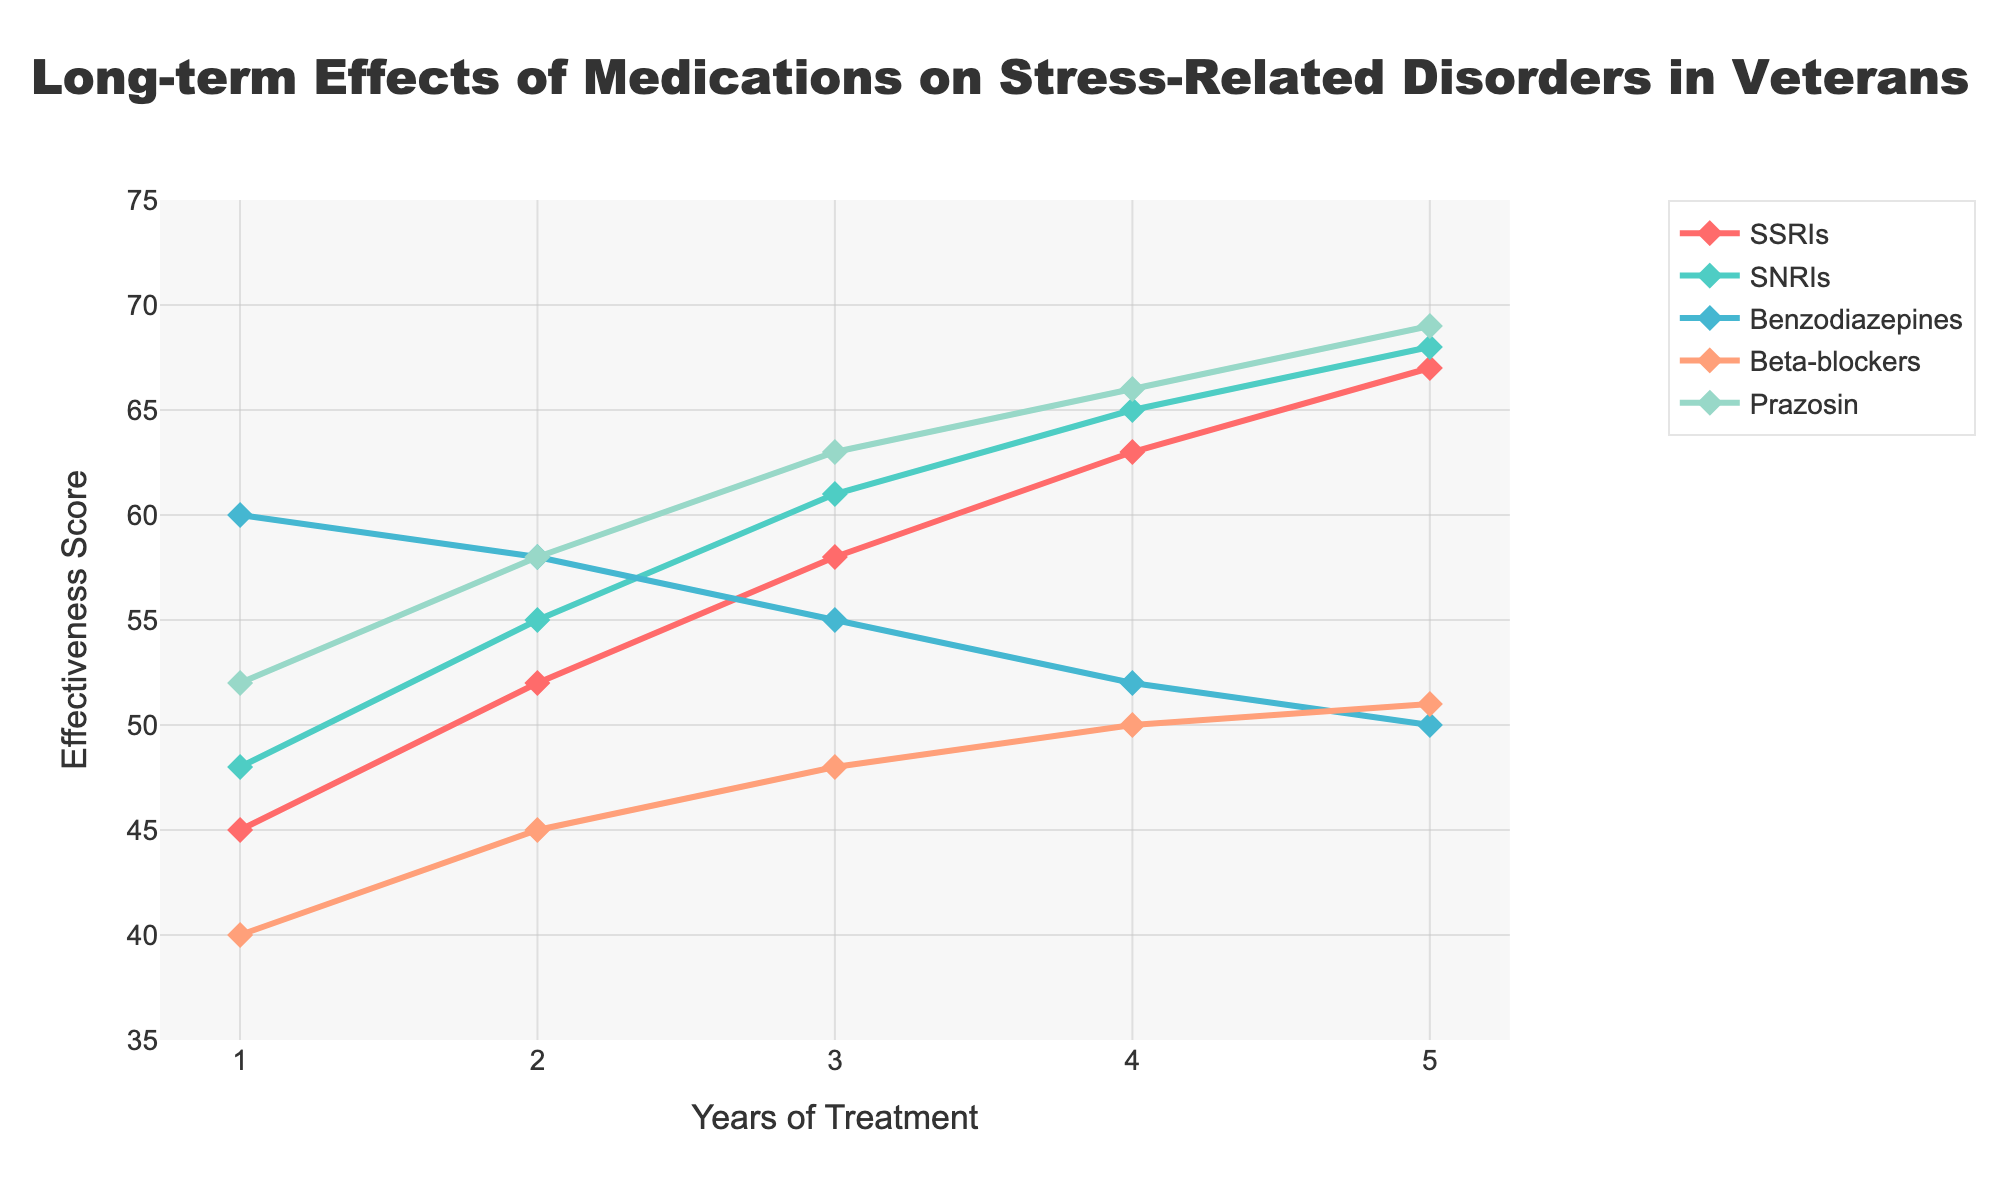What's the highest effectiveness score reached by any medication? Look at the y-axis for the highest point in the chart. Prazosin reaches the highest effectiveness score at year 5 with a score of 69.
Answer: 69 Which medication shows a steady increase in effectiveness over the years without any decrease? Examine the lines for each medication. SSRIs, SNRIs, Beta-blockers, and Prazosin all show a steady increase, but Benzodiazepines show a decrease.
Answer: SSRIs, SNRIs, Beta-blockers, Prazosin What is the difference in effectiveness score between years 1 and 5 for Benzodiazepines? Look at the effectiveness scores for Benzodiazepines at years 1 and 5. The score at year 1 is 60 and at year 5 is 50. The difference is 60 - 50 = 10.
Answer: 10 Which medication has an initial high effectiveness score but decreases over time? Identify the line that starts high and then drops. Benzodiazepines start at 60 and drop each year.
Answer: Benzodiazepines Among all medications, which one shows the greatest improvement in effectiveness from year 1 to year 5? Calculate the increase for each medication from year 1 to year 5. Prazosin shows an increase from 52 to 69, making the improvement 69 - 52 = 17.
Answer: Prazosin Which medication reaches an effectiveness score of 50 the earliest? Check which line reaches the score of 50 first. Benzodiazepines reach 50 at year 5, Beta-blockers at year 4, others later. Thus, Beta-blockers reach 50 in year 4.
Answer: Beta-blockers Compare the effectiveness scores of SSRIs and SNRIs in year 3. Which is higher, and by how much? Look at year 3 for both SSRIs and SNRIs. SSRIs have a score of 58 and SNRIs have a score of 61. The difference is 61 - 58 = 3, with SNRIs higher.
Answer: SNRIs by 3 What is the average effectiveness score of Beta-blockers over the 5 years? Add the scores for Beta-blockers over the 5 years and divide by 5: (40 + 45 + 48 + 50 + 51) / 5 = 46.8.
Answer: 46.8 By the fifth year, which medications have an effectiveness score greater than 65? Check the y-axis values for all medications in year 5. SNRIs, Prazosin, and SSRIs have scores of 68, 69, and 67 respectively.
Answer: SSRIs, SNRIs, Prazosin How does the trend of effectiveness for SSRIs compare to that of Prazosin from year 1 to year 5? Both SSRIs and Prazosin show a continuous increase in effectiveness, but Prazosin starts higher and also ends higher. The increase of Prazosin is slightly steeper.
Answer: Both increase, Prazosin steeper 